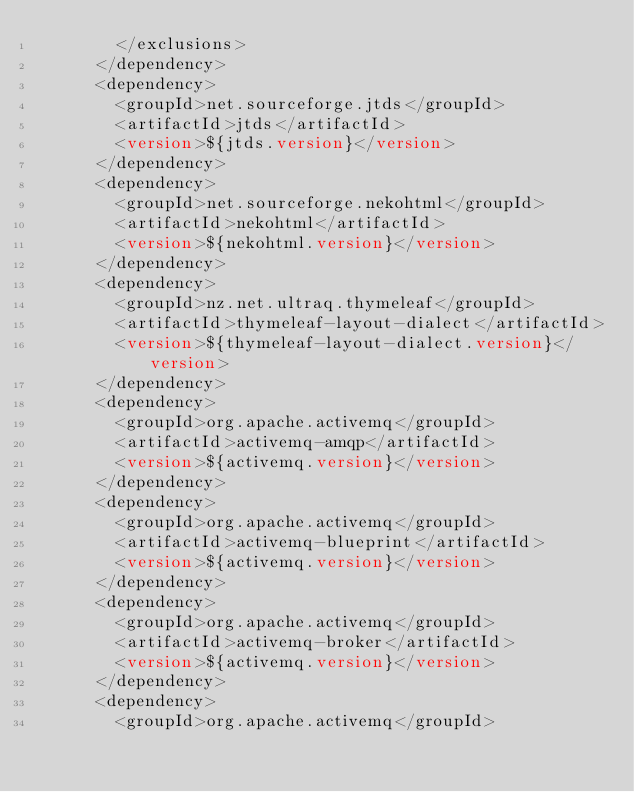Convert code to text. <code><loc_0><loc_0><loc_500><loc_500><_XML_>				</exclusions>
			</dependency>
			<dependency>
				<groupId>net.sourceforge.jtds</groupId>
				<artifactId>jtds</artifactId>
				<version>${jtds.version}</version>
			</dependency>
			<dependency>
				<groupId>net.sourceforge.nekohtml</groupId>
				<artifactId>nekohtml</artifactId>
				<version>${nekohtml.version}</version>
			</dependency>
			<dependency>
				<groupId>nz.net.ultraq.thymeleaf</groupId>
				<artifactId>thymeleaf-layout-dialect</artifactId>
				<version>${thymeleaf-layout-dialect.version}</version>
			</dependency>
			<dependency>
				<groupId>org.apache.activemq</groupId>
				<artifactId>activemq-amqp</artifactId>
				<version>${activemq.version}</version>
			</dependency>
			<dependency>
				<groupId>org.apache.activemq</groupId>
				<artifactId>activemq-blueprint</artifactId>
				<version>${activemq.version}</version>
			</dependency>
			<dependency>
				<groupId>org.apache.activemq</groupId>
				<artifactId>activemq-broker</artifactId>
				<version>${activemq.version}</version>
			</dependency>
			<dependency>
				<groupId>org.apache.activemq</groupId></code> 